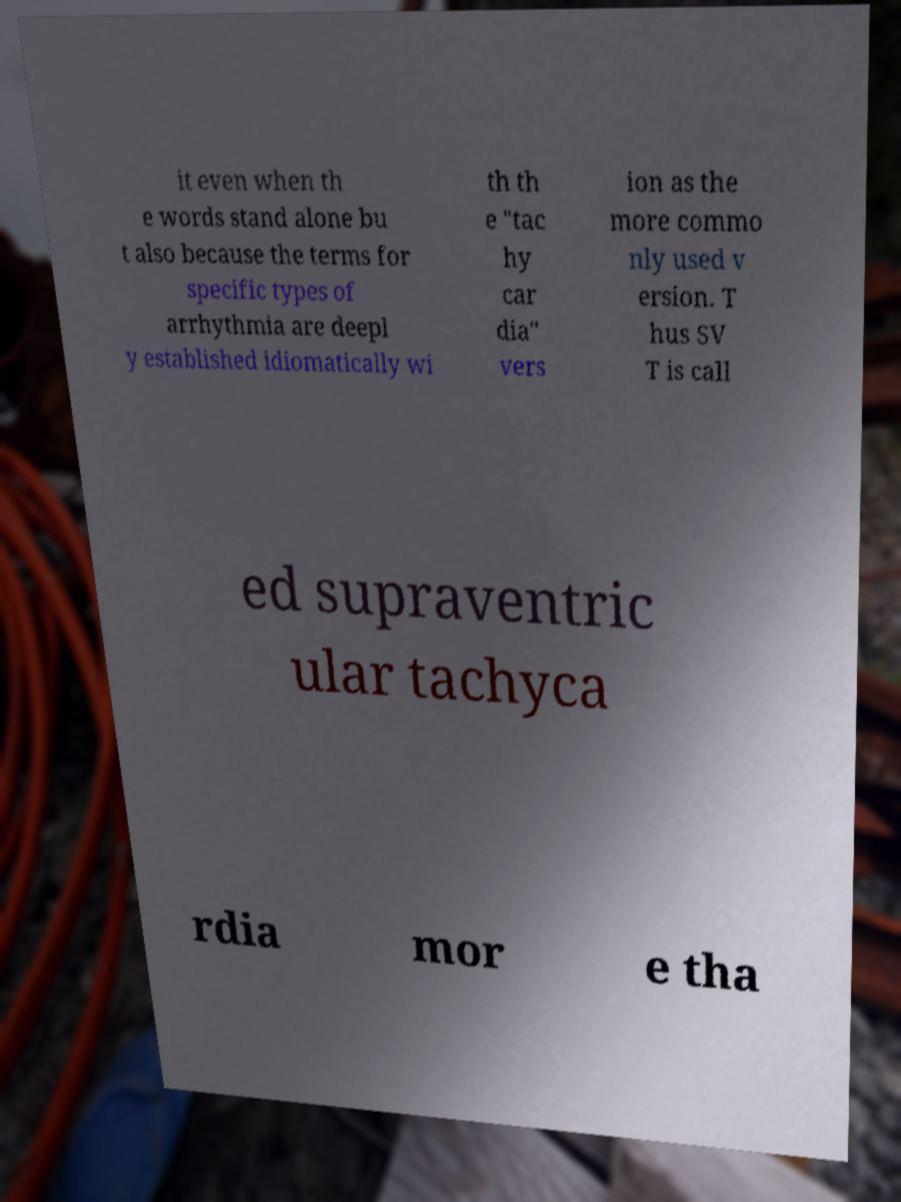Could you extract and type out the text from this image? it even when th e words stand alone bu t also because the terms for specific types of arrhythmia are deepl y established idiomatically wi th th e "tac hy car dia" vers ion as the more commo nly used v ersion. T hus SV T is call ed supraventric ular tachyca rdia mor e tha 